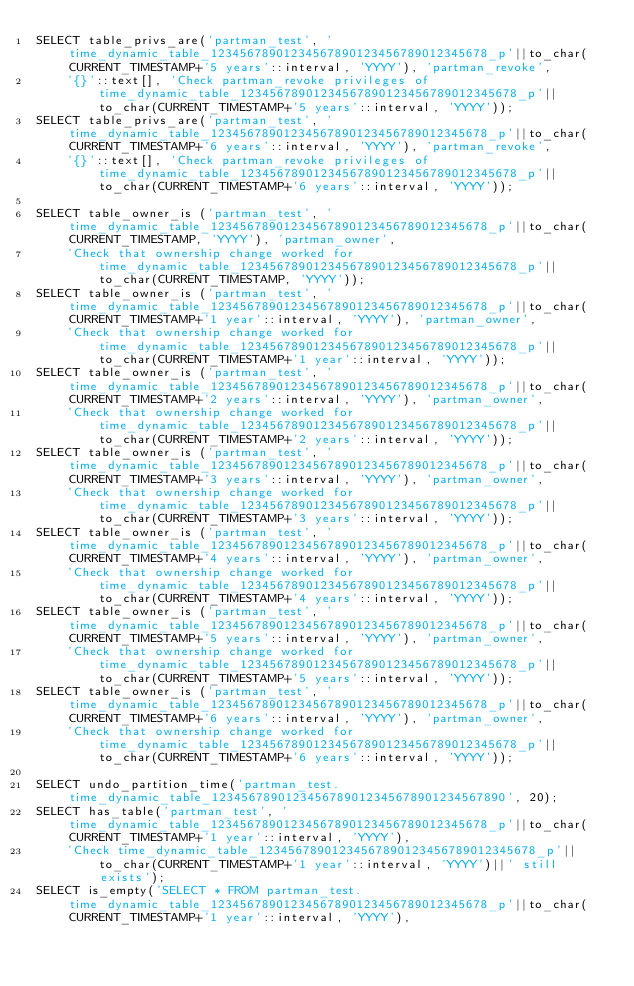Convert code to text. <code><loc_0><loc_0><loc_500><loc_500><_SQL_>SELECT table_privs_are('partman_test', 'time_dynamic_table_12345678901234567890123456789012345678_p'||to_char(CURRENT_TIMESTAMP+'5 years'::interval, 'YYYY'), 'partman_revoke', 
    '{}'::text[], 'Check partman_revoke privileges of time_dynamic_table_12345678901234567890123456789012345678_p'||to_char(CURRENT_TIMESTAMP+'5 years'::interval, 'YYYY'));
SELECT table_privs_are('partman_test', 'time_dynamic_table_12345678901234567890123456789012345678_p'||to_char(CURRENT_TIMESTAMP+'6 years'::interval, 'YYYY'), 'partman_revoke', 
    '{}'::text[], 'Check partman_revoke privileges of time_dynamic_table_12345678901234567890123456789012345678_p'||to_char(CURRENT_TIMESTAMP+'6 years'::interval, 'YYYY'));

SELECT table_owner_is ('partman_test', 'time_dynamic_table_12345678901234567890123456789012345678_p'||to_char(CURRENT_TIMESTAMP, 'YYYY'), 'partman_owner', 
    'Check that ownership change worked for time_dynamic_table_12345678901234567890123456789012345678_p'||to_char(CURRENT_TIMESTAMP, 'YYYY'));
SELECT table_owner_is ('partman_test', 'time_dynamic_table_12345678901234567890123456789012345678_p'||to_char(CURRENT_TIMESTAMP+'1 year'::interval, 'YYYY'), 'partman_owner', 
    'Check that ownership change worked for time_dynamic_table_12345678901234567890123456789012345678_p'||to_char(CURRENT_TIMESTAMP+'1 year'::interval, 'YYYY'));
SELECT table_owner_is ('partman_test', 'time_dynamic_table_12345678901234567890123456789012345678_p'||to_char(CURRENT_TIMESTAMP+'2 years'::interval, 'YYYY'), 'partman_owner', 
    'Check that ownership change worked for time_dynamic_table_12345678901234567890123456789012345678_p'||to_char(CURRENT_TIMESTAMP+'2 years'::interval, 'YYYY'));
SELECT table_owner_is ('partman_test', 'time_dynamic_table_12345678901234567890123456789012345678_p'||to_char(CURRENT_TIMESTAMP+'3 years'::interval, 'YYYY'), 'partman_owner', 
    'Check that ownership change worked for time_dynamic_table_12345678901234567890123456789012345678_p'||to_char(CURRENT_TIMESTAMP+'3 years'::interval, 'YYYY'));
SELECT table_owner_is ('partman_test', 'time_dynamic_table_12345678901234567890123456789012345678_p'||to_char(CURRENT_TIMESTAMP+'4 years'::interval, 'YYYY'), 'partman_owner', 
    'Check that ownership change worked for time_dynamic_table_12345678901234567890123456789012345678_p'||to_char(CURRENT_TIMESTAMP+'4 years'::interval, 'YYYY'));
SELECT table_owner_is ('partman_test', 'time_dynamic_table_12345678901234567890123456789012345678_p'||to_char(CURRENT_TIMESTAMP+'5 years'::interval, 'YYYY'), 'partman_owner', 
    'Check that ownership change worked for time_dynamic_table_12345678901234567890123456789012345678_p'||to_char(CURRENT_TIMESTAMP+'5 years'::interval, 'YYYY'));
SELECT table_owner_is ('partman_test', 'time_dynamic_table_12345678901234567890123456789012345678_p'||to_char(CURRENT_TIMESTAMP+'6 years'::interval, 'YYYY'), 'partman_owner', 
    'Check that ownership change worked for time_dynamic_table_12345678901234567890123456789012345678_p'||to_char(CURRENT_TIMESTAMP+'6 years'::interval, 'YYYY'));

SELECT undo_partition_time('partman_test.time_dynamic_table_1234567890123456789012345678901234567890', 20);
SELECT has_table('partman_test', 'time_dynamic_table_12345678901234567890123456789012345678_p'||to_char(CURRENT_TIMESTAMP+'1 year'::interval, 'YYYY'), 
    'Check time_dynamic_table_12345678901234567890123456789012345678_p'||to_char(CURRENT_TIMESTAMP+'1 year'::interval, 'YYYY')||' still exists');
SELECT is_empty('SELECT * FROM partman_test.time_dynamic_table_12345678901234567890123456789012345678_p'||to_char(CURRENT_TIMESTAMP+'1 year'::interval, 'YYYY'), </code> 